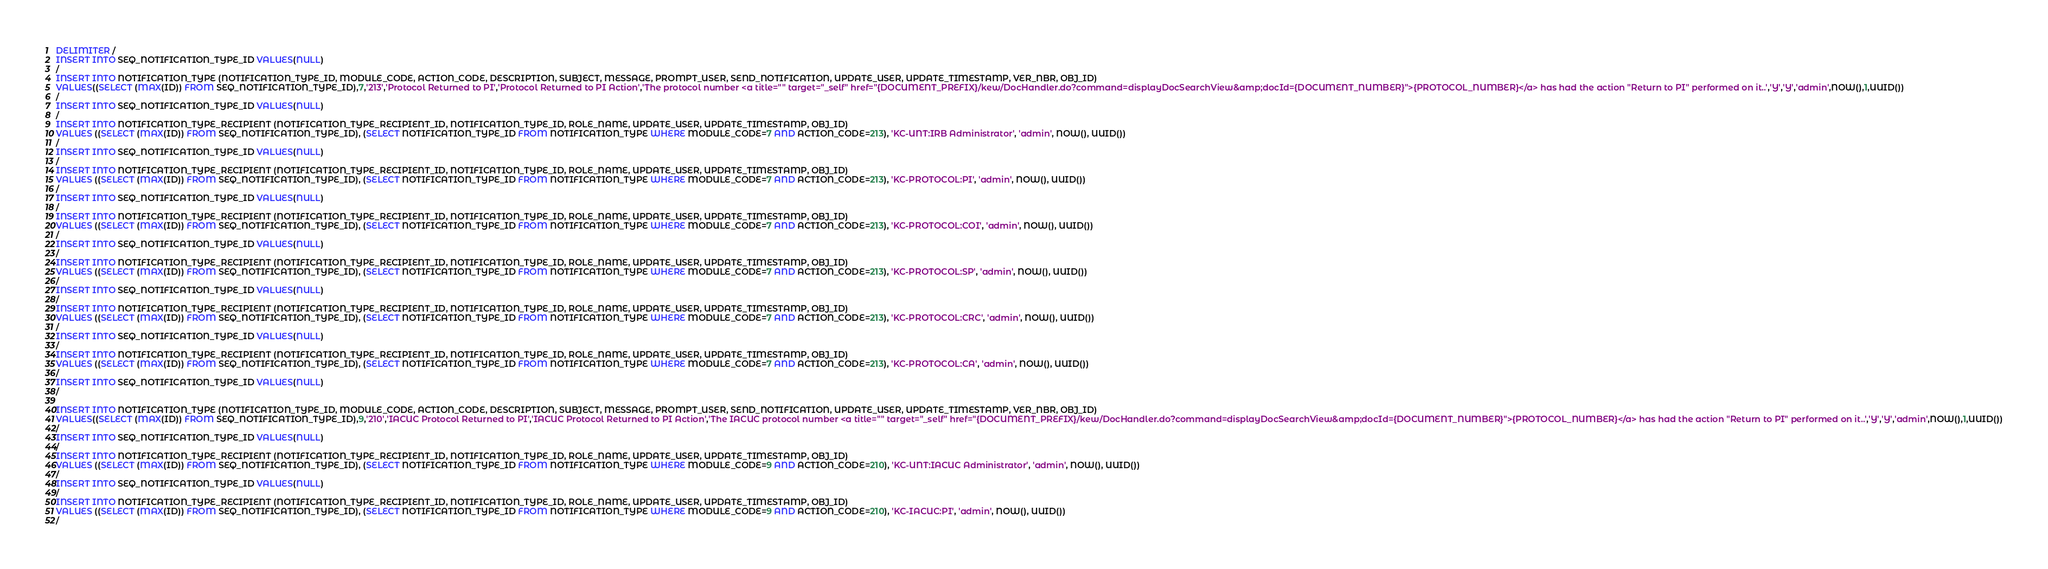Convert code to text. <code><loc_0><loc_0><loc_500><loc_500><_SQL_>DELIMITER /
INSERT INTO SEQ_NOTIFICATION_TYPE_ID VALUES(NULL)
/
INSERT INTO NOTIFICATION_TYPE (NOTIFICATION_TYPE_ID, MODULE_CODE, ACTION_CODE, DESCRIPTION, SUBJECT, MESSAGE, PROMPT_USER, SEND_NOTIFICATION, UPDATE_USER, UPDATE_TIMESTAMP, VER_NBR, OBJ_ID)
VALUES((SELECT (MAX(ID)) FROM SEQ_NOTIFICATION_TYPE_ID),7,'213','Protocol Returned to PI','Protocol Returned to PI Action','The protocol number <a title="" target="_self" href="{DOCUMENT_PREFIX}/kew/DocHandler.do?command=displayDocSearchView&amp;docId={DOCUMENT_NUMBER}">{PROTOCOL_NUMBER}</a> has had the action "Return to PI" performed on it..','Y','Y','admin',NOW(),1,UUID())
/
INSERT INTO SEQ_NOTIFICATION_TYPE_ID VALUES(NULL)
/
INSERT INTO NOTIFICATION_TYPE_RECIPIENT (NOTIFICATION_TYPE_RECIPIENT_ID, NOTIFICATION_TYPE_ID, ROLE_NAME, UPDATE_USER, UPDATE_TIMESTAMP, OBJ_ID)
VALUES ((SELECT (MAX(ID)) FROM SEQ_NOTIFICATION_TYPE_ID), (SELECT NOTIFICATION_TYPE_ID FROM NOTIFICATION_TYPE WHERE MODULE_CODE=7 AND ACTION_CODE=213), 'KC-UNT:IRB Administrator', 'admin', NOW(), UUID())
/
INSERT INTO SEQ_NOTIFICATION_TYPE_ID VALUES(NULL)
/
INSERT INTO NOTIFICATION_TYPE_RECIPIENT (NOTIFICATION_TYPE_RECIPIENT_ID, NOTIFICATION_TYPE_ID, ROLE_NAME, UPDATE_USER, UPDATE_TIMESTAMP, OBJ_ID)
VALUES ((SELECT (MAX(ID)) FROM SEQ_NOTIFICATION_TYPE_ID), (SELECT NOTIFICATION_TYPE_ID FROM NOTIFICATION_TYPE WHERE MODULE_CODE=7 AND ACTION_CODE=213), 'KC-PROTOCOL:PI', 'admin', NOW(), UUID())
/
INSERT INTO SEQ_NOTIFICATION_TYPE_ID VALUES(NULL)
/
INSERT INTO NOTIFICATION_TYPE_RECIPIENT (NOTIFICATION_TYPE_RECIPIENT_ID, NOTIFICATION_TYPE_ID, ROLE_NAME, UPDATE_USER, UPDATE_TIMESTAMP, OBJ_ID)
VALUES ((SELECT (MAX(ID)) FROM SEQ_NOTIFICATION_TYPE_ID), (SELECT NOTIFICATION_TYPE_ID FROM NOTIFICATION_TYPE WHERE MODULE_CODE=7 AND ACTION_CODE=213), 'KC-PROTOCOL:COI', 'admin', NOW(), UUID())
/
INSERT INTO SEQ_NOTIFICATION_TYPE_ID VALUES(NULL)
/
INSERT INTO NOTIFICATION_TYPE_RECIPIENT (NOTIFICATION_TYPE_RECIPIENT_ID, NOTIFICATION_TYPE_ID, ROLE_NAME, UPDATE_USER, UPDATE_TIMESTAMP, OBJ_ID)
VALUES ((SELECT (MAX(ID)) FROM SEQ_NOTIFICATION_TYPE_ID), (SELECT NOTIFICATION_TYPE_ID FROM NOTIFICATION_TYPE WHERE MODULE_CODE=7 AND ACTION_CODE=213), 'KC-PROTOCOL:SP', 'admin', NOW(), UUID())
/
INSERT INTO SEQ_NOTIFICATION_TYPE_ID VALUES(NULL)
/
INSERT INTO NOTIFICATION_TYPE_RECIPIENT (NOTIFICATION_TYPE_RECIPIENT_ID, NOTIFICATION_TYPE_ID, ROLE_NAME, UPDATE_USER, UPDATE_TIMESTAMP, OBJ_ID)
VALUES ((SELECT (MAX(ID)) FROM SEQ_NOTIFICATION_TYPE_ID), (SELECT NOTIFICATION_TYPE_ID FROM NOTIFICATION_TYPE WHERE MODULE_CODE=7 AND ACTION_CODE=213), 'KC-PROTOCOL:CRC', 'admin', NOW(), UUID())
/
INSERT INTO SEQ_NOTIFICATION_TYPE_ID VALUES(NULL)
/
INSERT INTO NOTIFICATION_TYPE_RECIPIENT (NOTIFICATION_TYPE_RECIPIENT_ID, NOTIFICATION_TYPE_ID, ROLE_NAME, UPDATE_USER, UPDATE_TIMESTAMP, OBJ_ID)
VALUES ((SELECT (MAX(ID)) FROM SEQ_NOTIFICATION_TYPE_ID), (SELECT NOTIFICATION_TYPE_ID FROM NOTIFICATION_TYPE WHERE MODULE_CODE=7 AND ACTION_CODE=213), 'KC-PROTOCOL:CA', 'admin', NOW(), UUID())
/
INSERT INTO SEQ_NOTIFICATION_TYPE_ID VALUES(NULL)
/

INSERT INTO NOTIFICATION_TYPE (NOTIFICATION_TYPE_ID, MODULE_CODE, ACTION_CODE, DESCRIPTION, SUBJECT, MESSAGE, PROMPT_USER, SEND_NOTIFICATION, UPDATE_USER, UPDATE_TIMESTAMP, VER_NBR, OBJ_ID)
VALUES((SELECT (MAX(ID)) FROM SEQ_NOTIFICATION_TYPE_ID),9,'210','IACUC Protocol Returned to PI','IACUC Protocol Returned to PI Action','The IACUC protocol number <a title="" target="_self" href="{DOCUMENT_PREFIX}/kew/DocHandler.do?command=displayDocSearchView&amp;docId={DOCUMENT_NUMBER}">{PROTOCOL_NUMBER}</a> has had the action "Return to PI" performed on it..','Y','Y','admin',NOW(),1,UUID())
/
INSERT INTO SEQ_NOTIFICATION_TYPE_ID VALUES(NULL)
/
INSERT INTO NOTIFICATION_TYPE_RECIPIENT (NOTIFICATION_TYPE_RECIPIENT_ID, NOTIFICATION_TYPE_ID, ROLE_NAME, UPDATE_USER, UPDATE_TIMESTAMP, OBJ_ID)
VALUES ((SELECT (MAX(ID)) FROM SEQ_NOTIFICATION_TYPE_ID), (SELECT NOTIFICATION_TYPE_ID FROM NOTIFICATION_TYPE WHERE MODULE_CODE=9 AND ACTION_CODE=210), 'KC-UNT:IACUC Administrator', 'admin', NOW(), UUID())
/
INSERT INTO SEQ_NOTIFICATION_TYPE_ID VALUES(NULL)
/
INSERT INTO NOTIFICATION_TYPE_RECIPIENT (NOTIFICATION_TYPE_RECIPIENT_ID, NOTIFICATION_TYPE_ID, ROLE_NAME, UPDATE_USER, UPDATE_TIMESTAMP, OBJ_ID)
VALUES ((SELECT (MAX(ID)) FROM SEQ_NOTIFICATION_TYPE_ID), (SELECT NOTIFICATION_TYPE_ID FROM NOTIFICATION_TYPE WHERE MODULE_CODE=9 AND ACTION_CODE=210), 'KC-IACUC:PI', 'admin', NOW(), UUID())
/</code> 